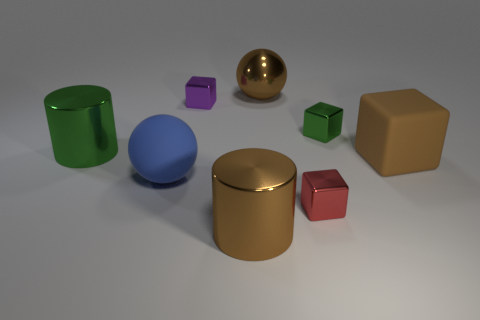What number of matte things are small purple things or blocks?
Your answer should be compact. 1. There is a brown block that is the same size as the brown shiny sphere; what material is it?
Offer a terse response. Rubber. How many other things are the same material as the small green object?
Your response must be concise. 5. Is the number of green metallic objects that are behind the large green metal object less than the number of small purple blocks?
Keep it short and to the point. No. Does the big blue rubber thing have the same shape as the large green thing?
Your answer should be compact. No. How big is the matte block that is to the right of the tiny metal thing left of the big brown thing behind the tiny purple shiny object?
Your answer should be compact. Large. There is a brown object that is the same shape as the red thing; what material is it?
Ensure brevity in your answer.  Rubber. How big is the brown object that is on the right side of the metallic object behind the purple cube?
Offer a very short reply. Large. The large shiny ball is what color?
Provide a short and direct response. Brown. There is a large brown metal object behind the red metal thing; how many brown cubes are behind it?
Keep it short and to the point. 0. 